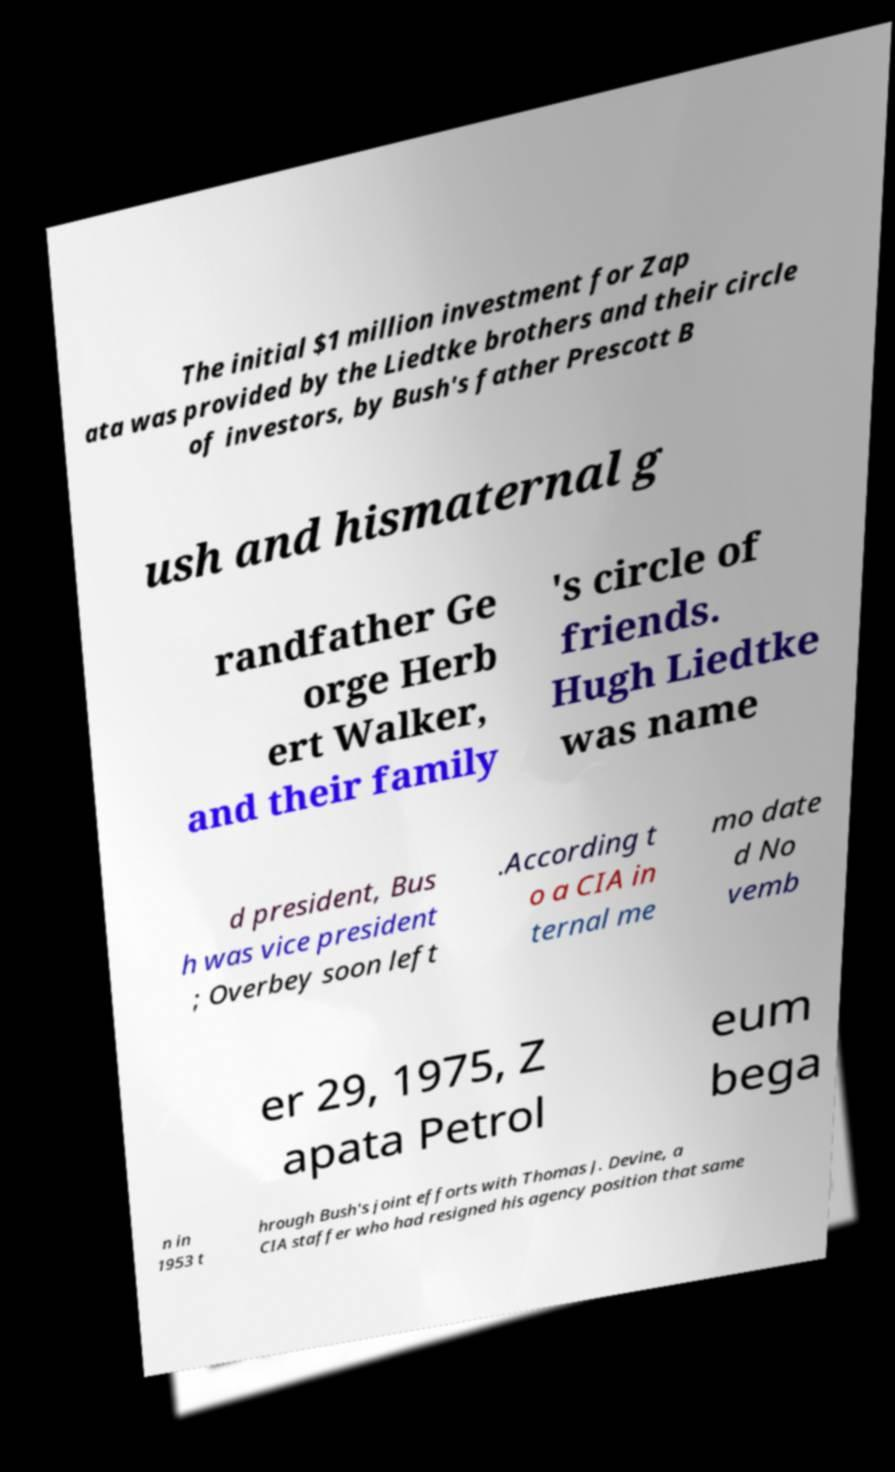For documentation purposes, I need the text within this image transcribed. Could you provide that? The initial $1 million investment for Zap ata was provided by the Liedtke brothers and their circle of investors, by Bush's father Prescott B ush and hismaternal g randfather Ge orge Herb ert Walker, and their family 's circle of friends. Hugh Liedtke was name d president, Bus h was vice president ; Overbey soon left .According t o a CIA in ternal me mo date d No vemb er 29, 1975, Z apata Petrol eum bega n in 1953 t hrough Bush's joint efforts with Thomas J. Devine, a CIA staffer who had resigned his agency position that same 